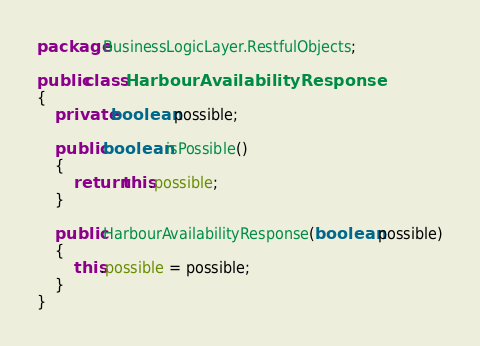<code> <loc_0><loc_0><loc_500><loc_500><_Java_>package BusinessLogicLayer.RestfulObjects;

public class HarbourAvailabilityResponse
{
    private boolean possible;

    public boolean isPossible()
    {
        return this.possible;
    }

    public HarbourAvailabilityResponse(boolean possible)
    {
        this.possible = possible;
    }
}
</code> 